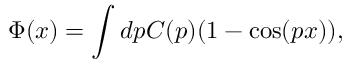<formula> <loc_0><loc_0><loc_500><loc_500>\Phi ( x ) = \int d p C ( p ) ( 1 - \cos ( p x ) ) ,</formula> 